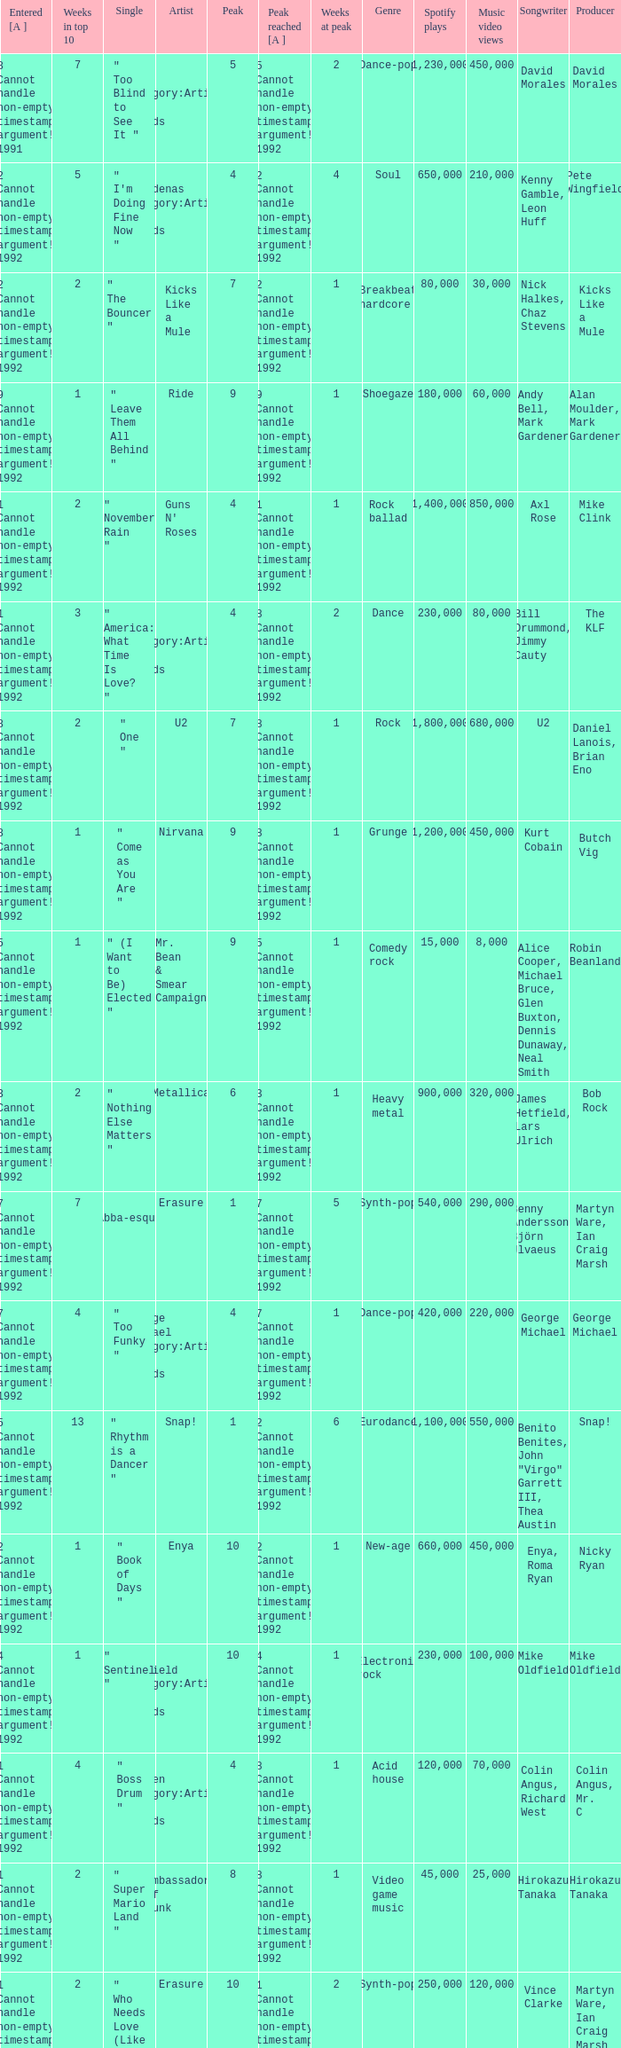If the peak is 9, how many weeks was it in the top 10? 1.0. 